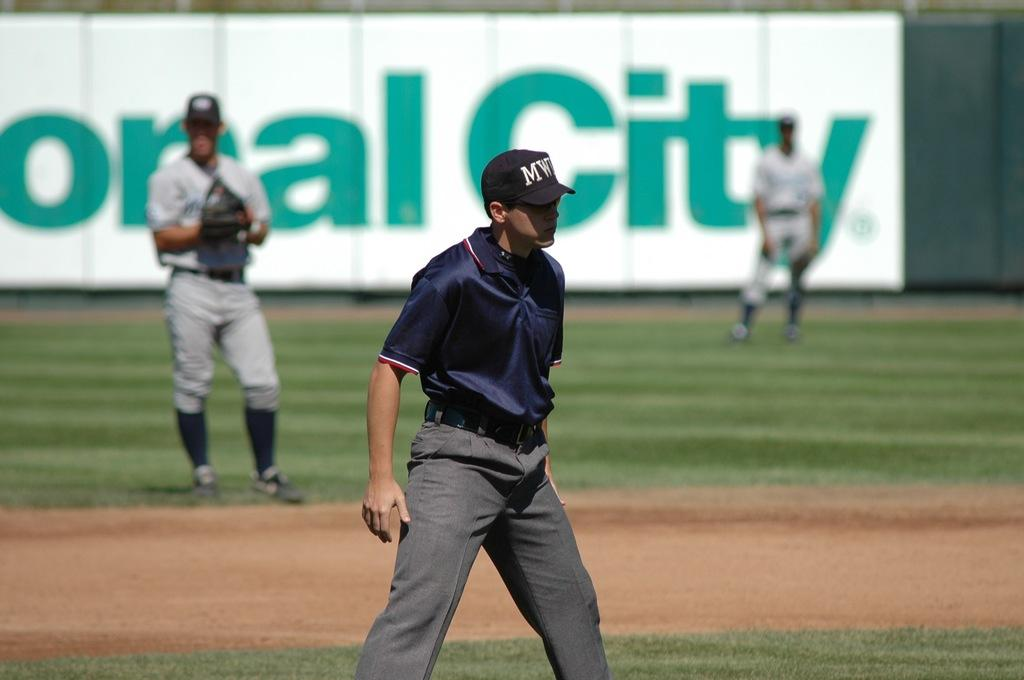Provide a one-sentence caption for the provided image. An ump has a hat on with a logo that starts with the letter M. 